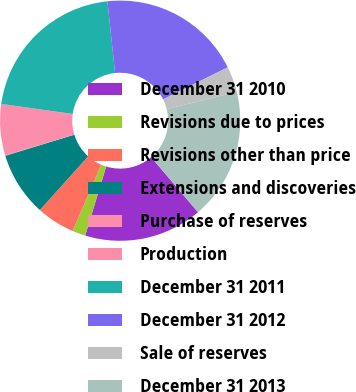Convert chart to OTSL. <chart><loc_0><loc_0><loc_500><loc_500><pie_chart><fcel>December 31 2010<fcel>Revisions due to prices<fcel>Revisions other than price<fcel>Extensions and discoveries<fcel>Purchase of reserves<fcel>Production<fcel>December 31 2011<fcel>December 31 2012<fcel>Sale of reserves<fcel>December 31 2013<nl><fcel>15.92%<fcel>1.76%<fcel>5.19%<fcel>8.63%<fcel>0.04%<fcel>6.91%<fcel>21.08%<fcel>19.36%<fcel>3.47%<fcel>17.64%<nl></chart> 